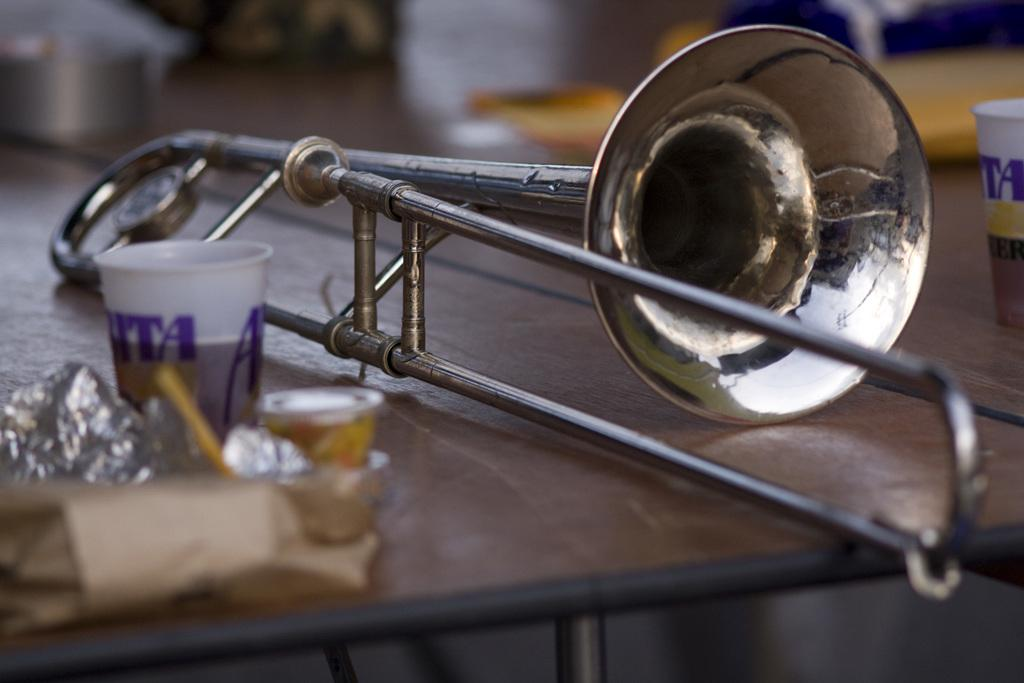What type of object is the main subject in the image? There is a musical instrument in the image. What else can be seen on the table in the image? There are glasses and other objects placed on the table. Can you describe the background of the image? The background of the image is blurry. How many slaves are visible in the image? There are no slaves present in the image. What type of doll is sitting on the table in the image? There is no doll present in the image. 